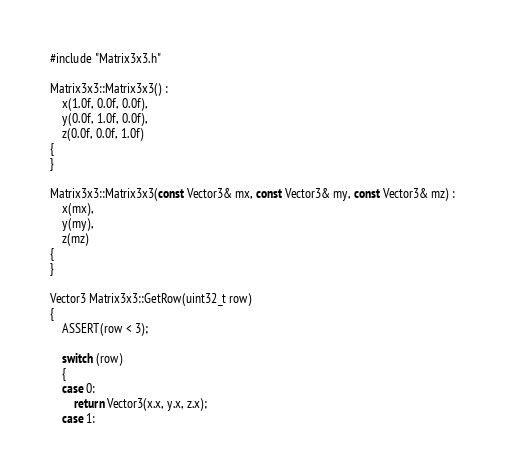Convert code to text. <code><loc_0><loc_0><loc_500><loc_500><_C++_>#include "Matrix3x3.h"

Matrix3x3::Matrix3x3() :
	x(1.0f, 0.0f, 0.0f),
	y(0.0f, 1.0f, 0.0f),
	z(0.0f, 0.0f, 1.0f)
{
}

Matrix3x3::Matrix3x3(const Vector3& mx, const Vector3& my, const Vector3& mz) :
	x(mx),
	y(my),
	z(mz)
{
}

Vector3 Matrix3x3::GetRow(uint32_t row)
{
	ASSERT(row < 3);

	switch (row)
	{
	case 0:
		return Vector3(x.x, y.x, z.x);
	case 1:</code> 